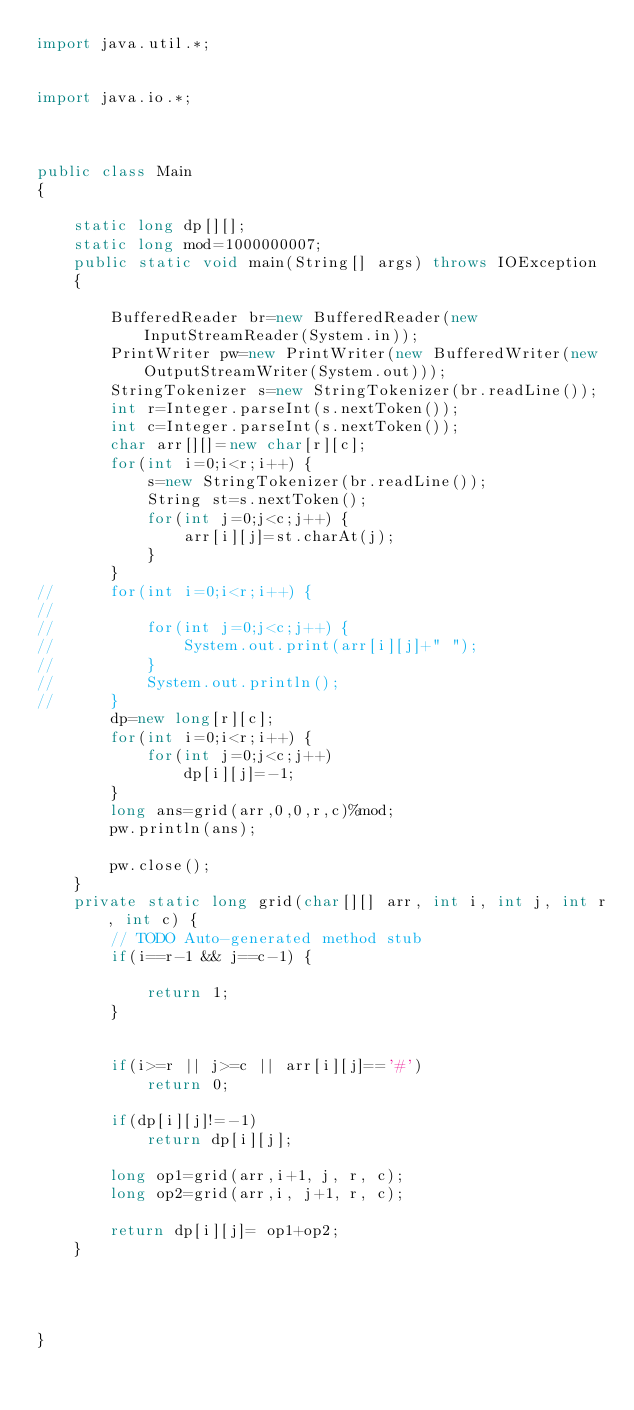Convert code to text. <code><loc_0><loc_0><loc_500><loc_500><_Java_>import java.util.*;


import java.io.*;



public class Main 
{   
	
	static long dp[][];
	static long mod=1000000007;
	public static void main(String[] args) throws IOException 
	{ 
		 
		BufferedReader br=new BufferedReader(new InputStreamReader(System.in));
		PrintWriter pw=new PrintWriter(new BufferedWriter(new OutputStreamWriter(System.out)));
		StringTokenizer s=new StringTokenizer(br.readLine());
		int r=Integer.parseInt(s.nextToken());
		int c=Integer.parseInt(s.nextToken());
		char arr[][]=new char[r][c];
		for(int i=0;i<r;i++) {
			s=new StringTokenizer(br.readLine());
			String st=s.nextToken();
			for(int j=0;j<c;j++) {
				arr[i][j]=st.charAt(j);
			}
		}
//		for(int i=0;i<r;i++) {
//			
//			for(int j=0;j<c;j++) {
//				System.out.print(arr[i][j]+" ");
//			}
//			System.out.println();
//		}
		dp=new long[r][c];
		for(int i=0;i<r;i++) {
			for(int j=0;j<c;j++)
				dp[i][j]=-1;
		}
		long ans=grid(arr,0,0,r,c)%mod;
		pw.println(ans);
		
		pw.close();
	}
	private static long grid(char[][] arr, int i, int j, int r, int c) {
		// TODO Auto-generated method stub
		if(i==r-1 && j==c-1) {
			
			return 1;
		}
		
		
		if(i>=r || j>=c || arr[i][j]=='#')
			return 0;
		
		if(dp[i][j]!=-1)
			return dp[i][j];
		
		long op1=grid(arr,i+1, j, r, c);
		long op2=grid(arr,i, j+1, r, c);
		
		return dp[i][j]= op1+op2;
	}
	
	
	
	
}</code> 